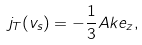<formula> <loc_0><loc_0><loc_500><loc_500>j _ { T } ( v _ { s } ) = - \frac { 1 } { 3 } A k e _ { z } ,</formula> 